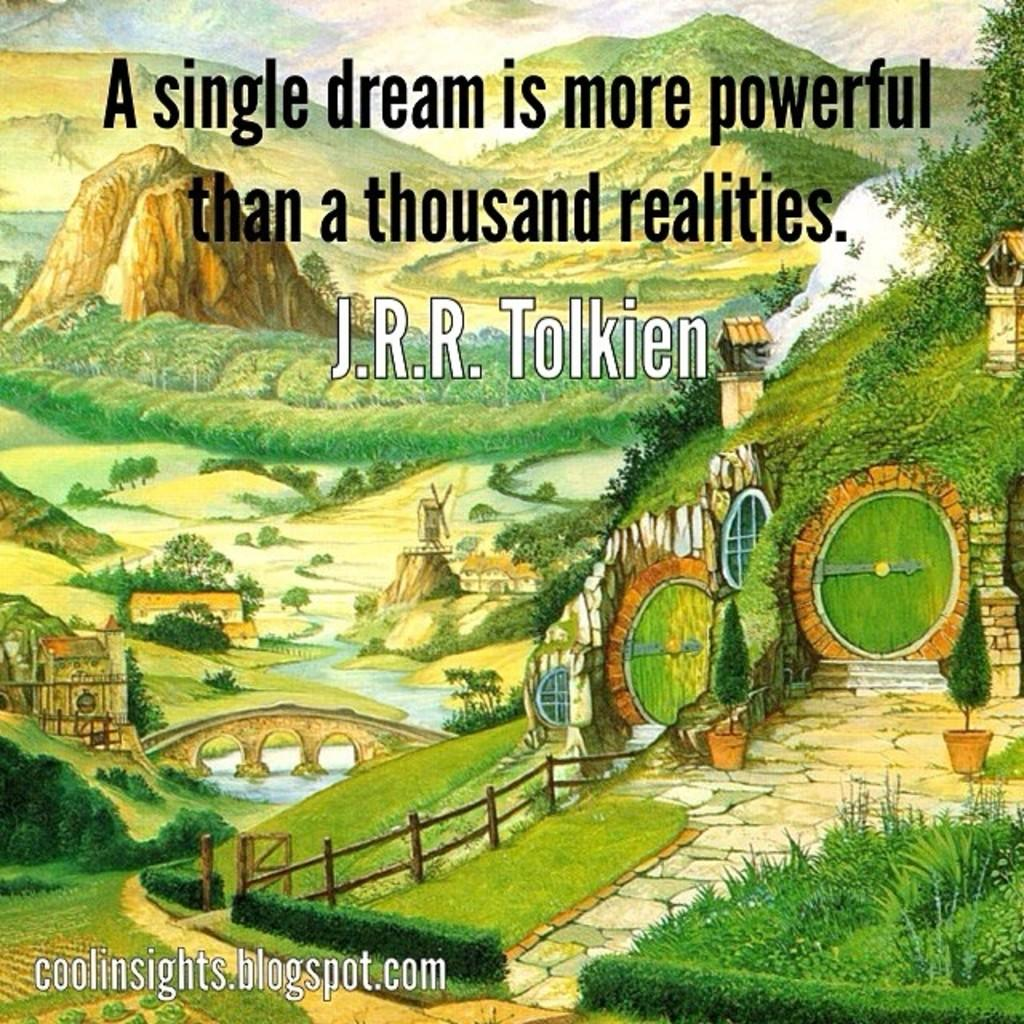What type of structures are depicted in the image? There are depictions of houses in the image. What type of geographical feature is depicted in the image? There is a depiction of a bridge in the image. What type of natural landmarks are depicted in the image? There are depictions of mountains, trees, a river, and grass in the image. Is there any text present in the image? Yes, there is some text in the image. Can you describe the driving activity taking place in the image? There is no driving activity present in the image. Is there a fight depicted in the image? There is no fight depicted in the image. 